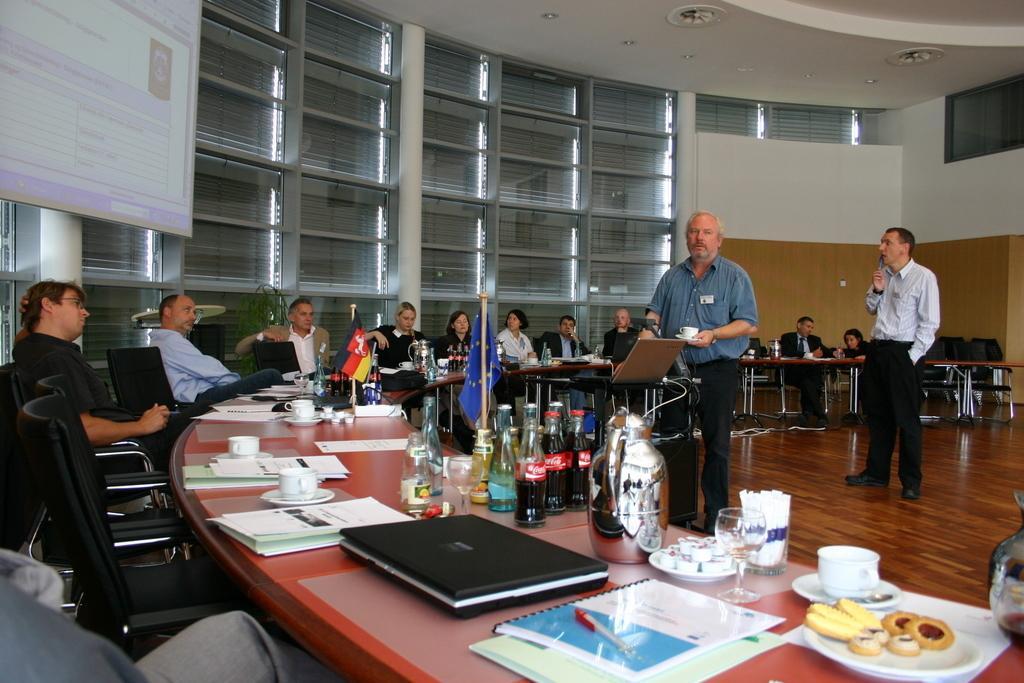Describe this image in one or two sentences. This image is taken inside a meeting room. There are few people in this room. In the right side of the image there is a floor and a table on which there are many things. In the left side of the image a man is sitting on the chair and few chairs are empty. In the middle of the image there is a table and there are many things on top of it. Two men are standing on the floor holding a cup and saucer in his hand. In the background there is a wall with a projector screen on it. At the top of the image there is a ceiling with lights. 